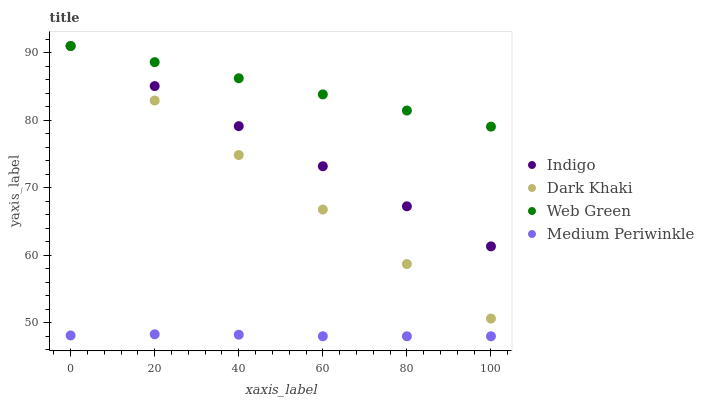Does Medium Periwinkle have the minimum area under the curve?
Answer yes or no. Yes. Does Web Green have the maximum area under the curve?
Answer yes or no. Yes. Does Indigo have the minimum area under the curve?
Answer yes or no. No. Does Indigo have the maximum area under the curve?
Answer yes or no. No. Is Dark Khaki the smoothest?
Answer yes or no. Yes. Is Medium Periwinkle the roughest?
Answer yes or no. Yes. Is Medium Periwinkle the smoothest?
Answer yes or no. No. Is Indigo the roughest?
Answer yes or no. No. Does Medium Periwinkle have the lowest value?
Answer yes or no. Yes. Does Indigo have the lowest value?
Answer yes or no. No. Does Web Green have the highest value?
Answer yes or no. Yes. Does Medium Periwinkle have the highest value?
Answer yes or no. No. Is Medium Periwinkle less than Web Green?
Answer yes or no. Yes. Is Indigo greater than Medium Periwinkle?
Answer yes or no. Yes. Does Dark Khaki intersect Indigo?
Answer yes or no. Yes. Is Dark Khaki less than Indigo?
Answer yes or no. No. Is Dark Khaki greater than Indigo?
Answer yes or no. No. Does Medium Periwinkle intersect Web Green?
Answer yes or no. No. 